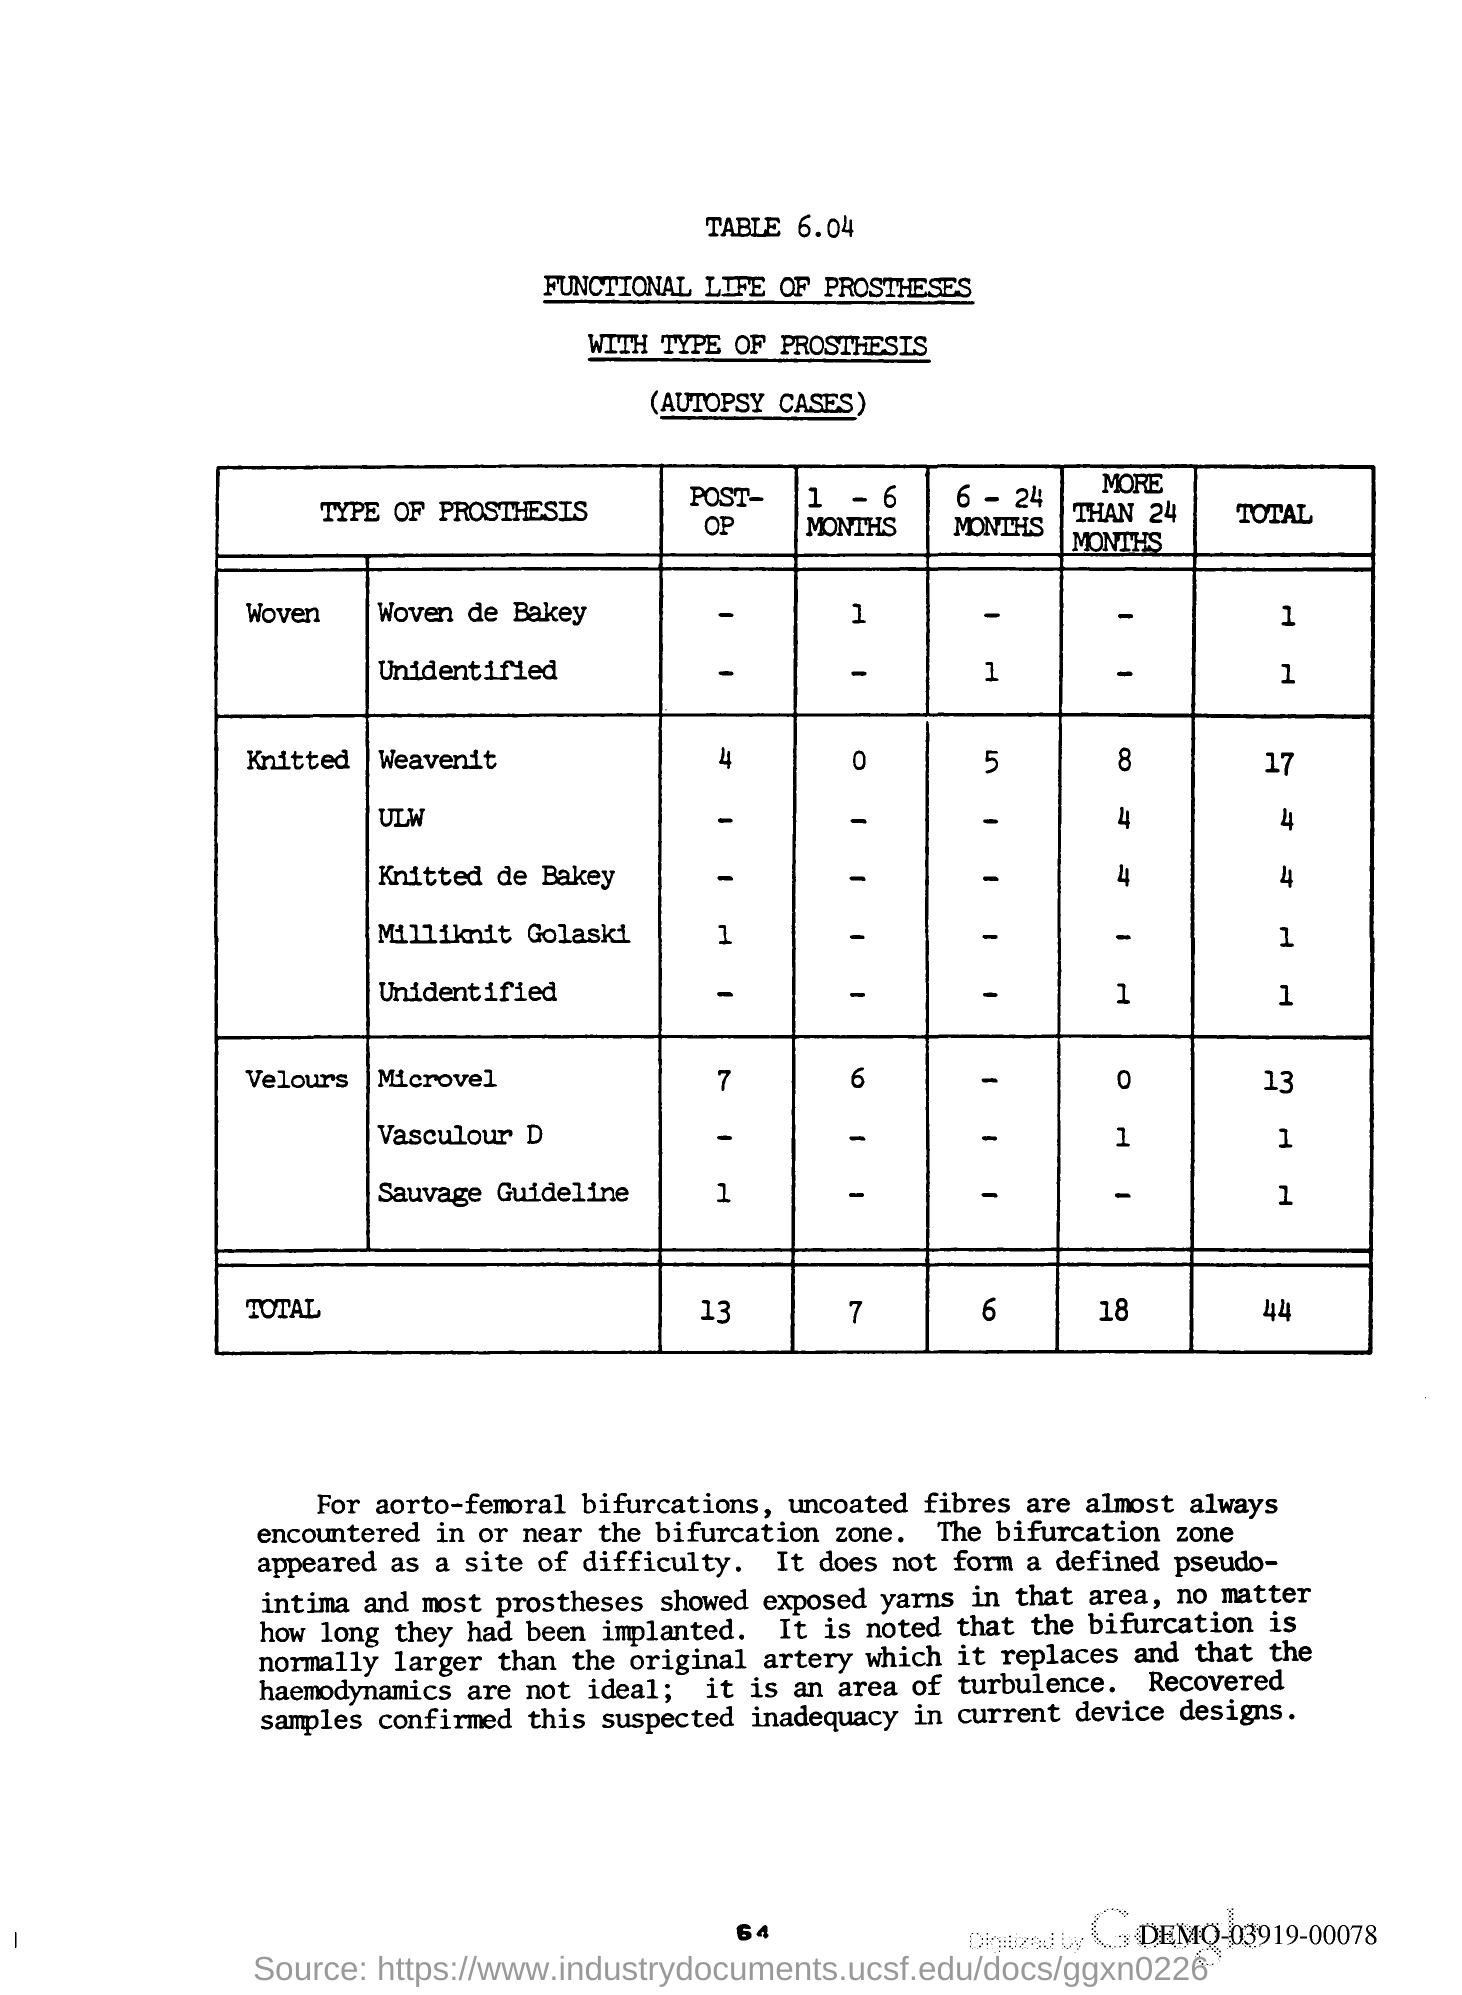What is the total Post-op?
Your answer should be very brief. 13. 